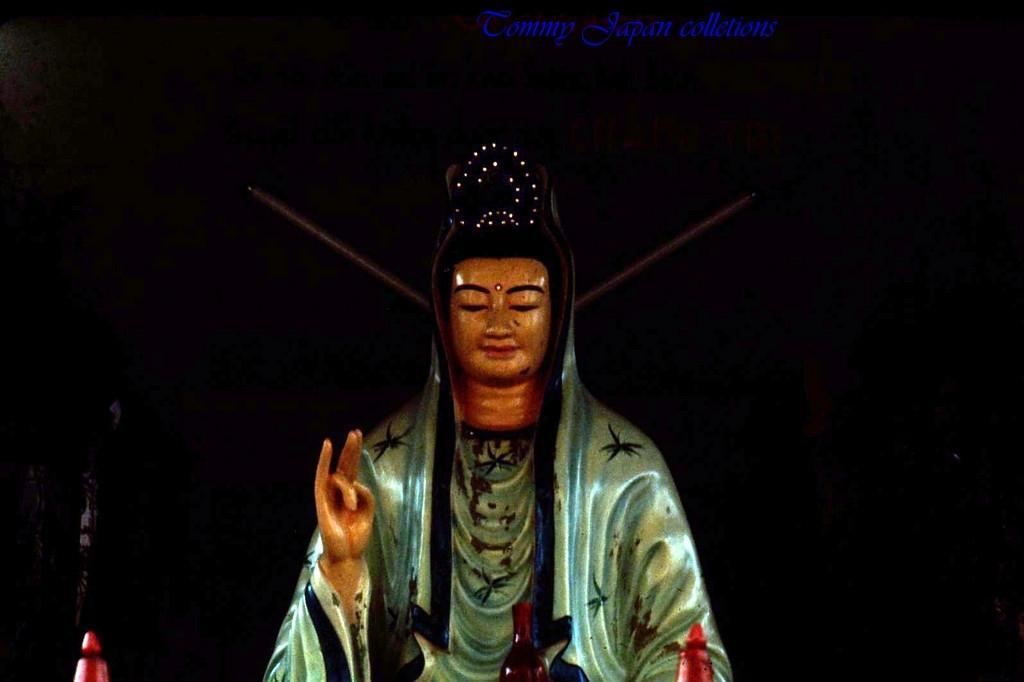Can you describe this image briefly? In the picture there is a statute and the background of the statue is dark. 